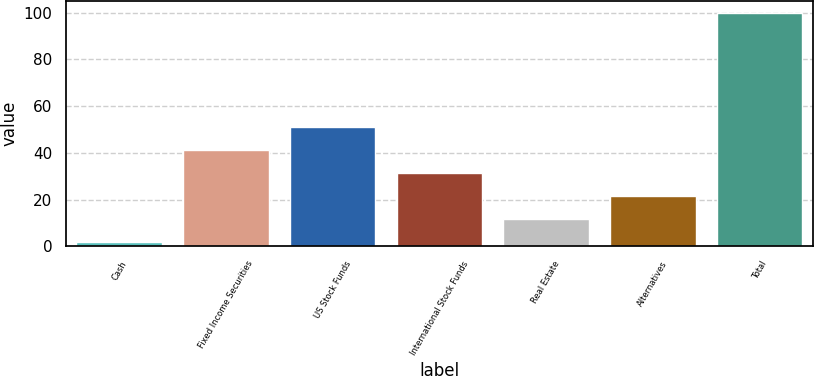<chart> <loc_0><loc_0><loc_500><loc_500><bar_chart><fcel>Cash<fcel>Fixed Income Securities<fcel>US Stock Funds<fcel>International Stock Funds<fcel>Real Estate<fcel>Alternatives<fcel>Total<nl><fcel>1.9<fcel>41.14<fcel>50.95<fcel>31.33<fcel>11.71<fcel>21.52<fcel>100<nl></chart> 